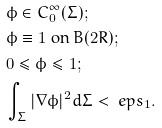<formula> <loc_0><loc_0><loc_500><loc_500>& \phi \in C ^ { \infty } _ { 0 } { ( \Sigma ) ; } \\ & \phi \equiv 1 \text { on } B ( 2 R ) ; \\ & 0 \leq \phi \leq 1 ; \\ & \int _ { \Sigma } | \nabla \phi | ^ { 2 } d \Sigma < \ e p s _ { 1 } .</formula> 